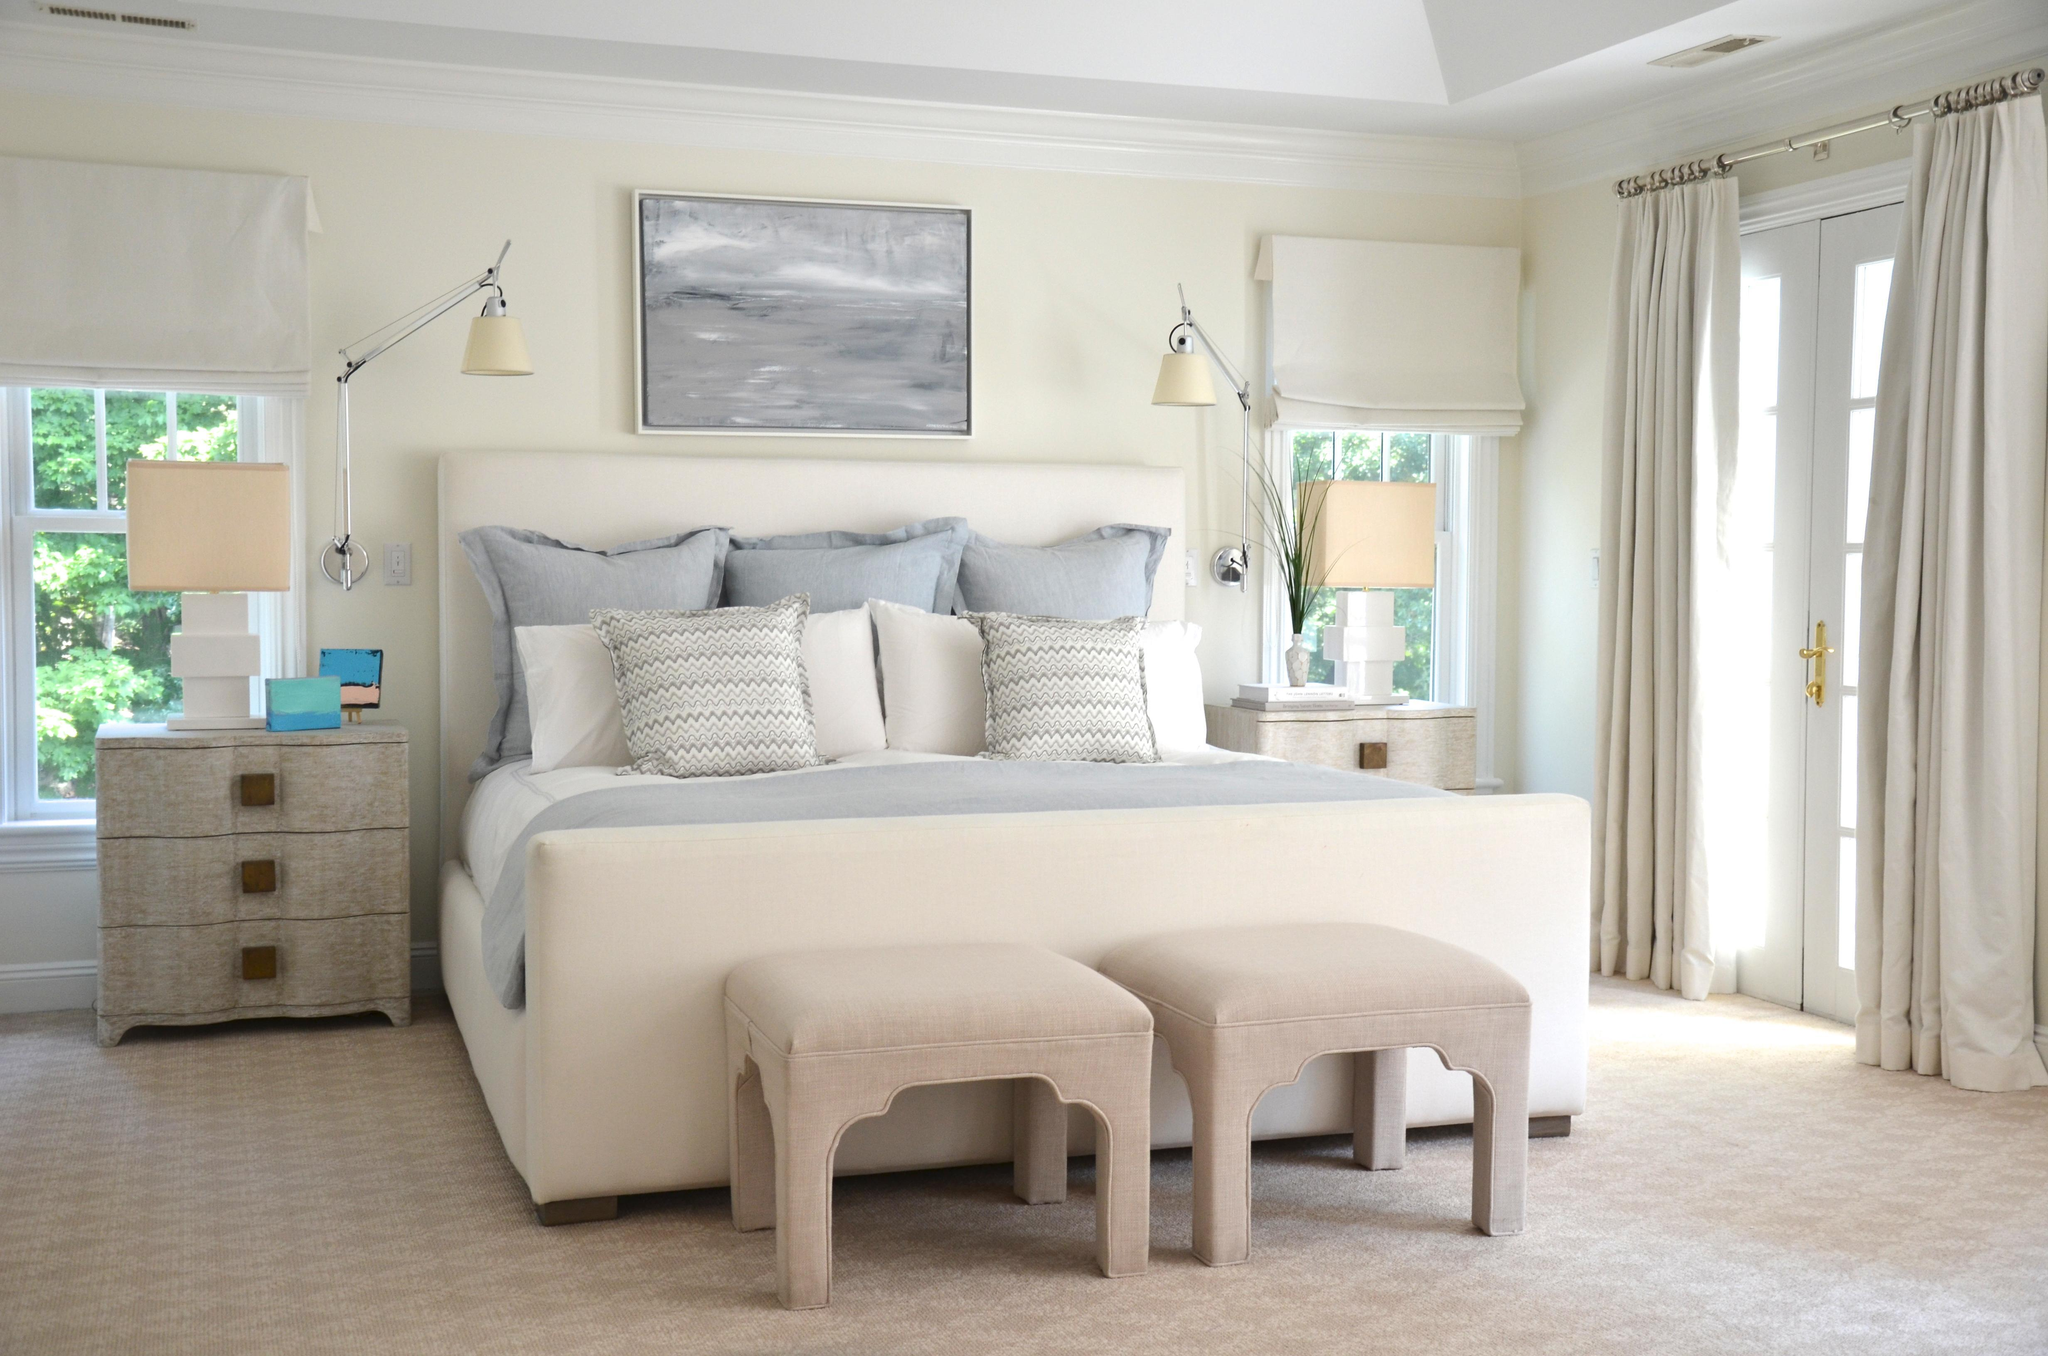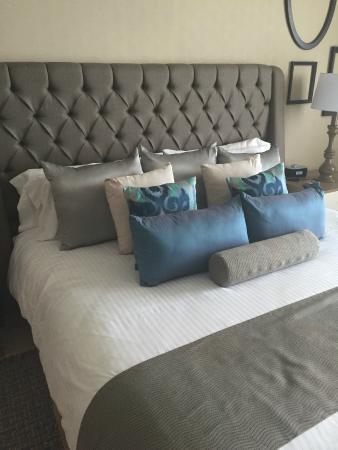The first image is the image on the left, the second image is the image on the right. Examine the images to the left and right. Is the description "There are exactly two table lamps in the image on the left." accurate? Answer yes or no. Yes. 